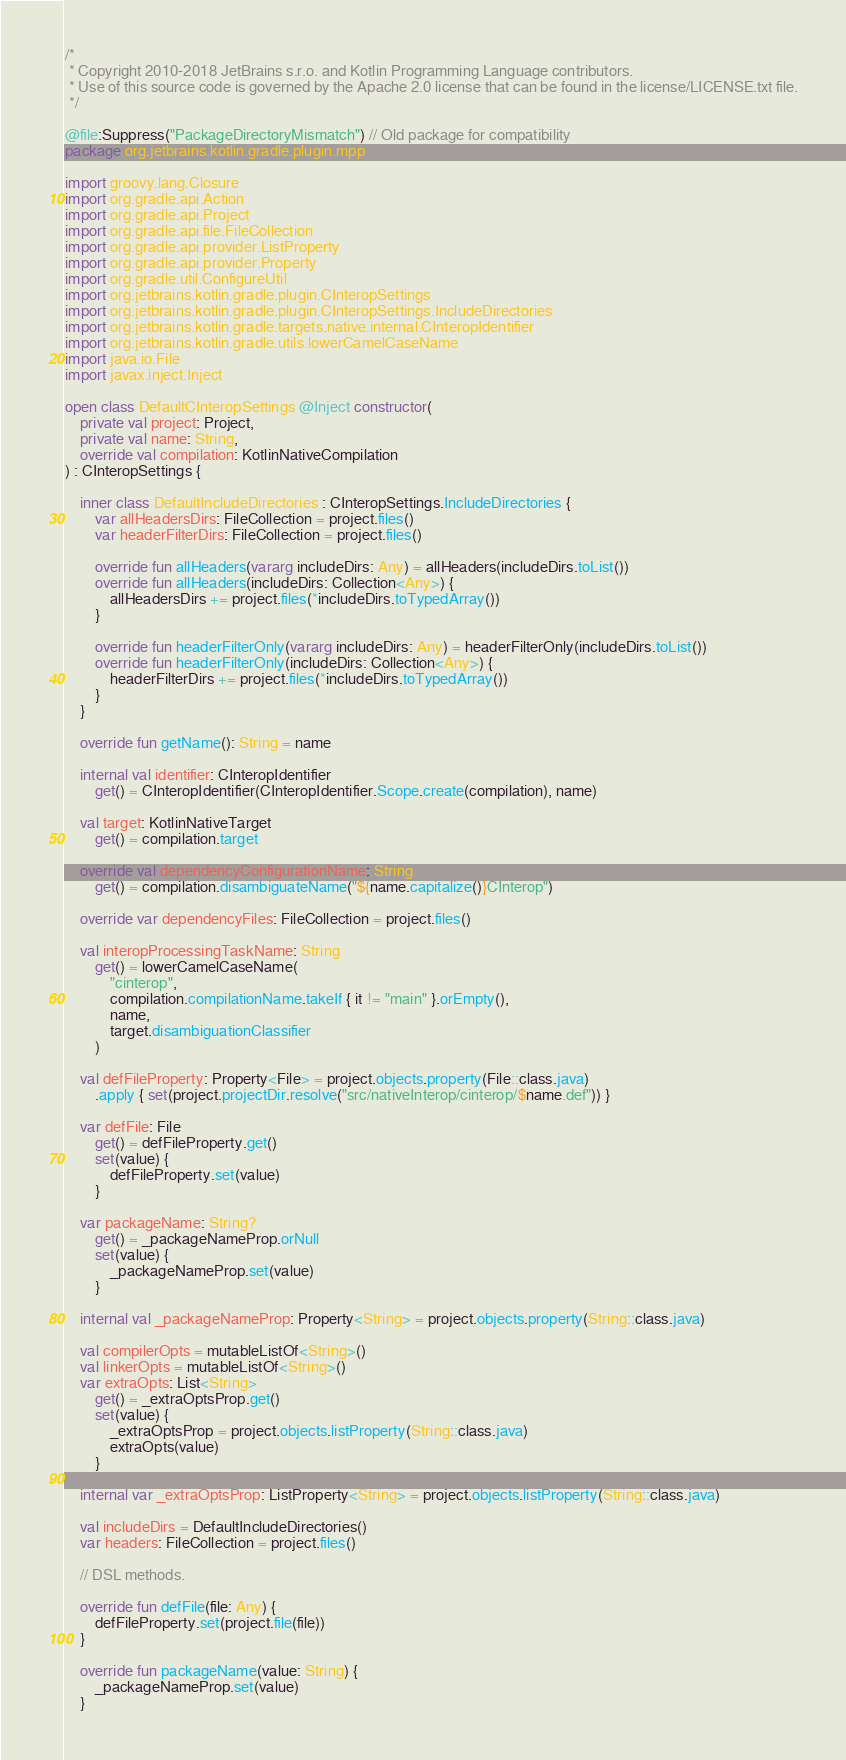<code> <loc_0><loc_0><loc_500><loc_500><_Kotlin_>/*
 * Copyright 2010-2018 JetBrains s.r.o. and Kotlin Programming Language contributors.
 * Use of this source code is governed by the Apache 2.0 license that can be found in the license/LICENSE.txt file.
 */

@file:Suppress("PackageDirectoryMismatch") // Old package for compatibility
package org.jetbrains.kotlin.gradle.plugin.mpp

import groovy.lang.Closure
import org.gradle.api.Action
import org.gradle.api.Project
import org.gradle.api.file.FileCollection
import org.gradle.api.provider.ListProperty
import org.gradle.api.provider.Property
import org.gradle.util.ConfigureUtil
import org.jetbrains.kotlin.gradle.plugin.CInteropSettings
import org.jetbrains.kotlin.gradle.plugin.CInteropSettings.IncludeDirectories
import org.jetbrains.kotlin.gradle.targets.native.internal.CInteropIdentifier
import org.jetbrains.kotlin.gradle.utils.lowerCamelCaseName
import java.io.File
import javax.inject.Inject

open class DefaultCInteropSettings @Inject constructor(
    private val project: Project,
    private val name: String,
    override val compilation: KotlinNativeCompilation
) : CInteropSettings {

    inner class DefaultIncludeDirectories : CInteropSettings.IncludeDirectories {
        var allHeadersDirs: FileCollection = project.files()
        var headerFilterDirs: FileCollection = project.files()

        override fun allHeaders(vararg includeDirs: Any) = allHeaders(includeDirs.toList())
        override fun allHeaders(includeDirs: Collection<Any>) {
            allHeadersDirs += project.files(*includeDirs.toTypedArray())
        }

        override fun headerFilterOnly(vararg includeDirs: Any) = headerFilterOnly(includeDirs.toList())
        override fun headerFilterOnly(includeDirs: Collection<Any>) {
            headerFilterDirs += project.files(*includeDirs.toTypedArray())
        }
    }

    override fun getName(): String = name

    internal val identifier: CInteropIdentifier
        get() = CInteropIdentifier(CInteropIdentifier.Scope.create(compilation), name)

    val target: KotlinNativeTarget
        get() = compilation.target

    override val dependencyConfigurationName: String
        get() = compilation.disambiguateName("${name.capitalize()}CInterop")

    override var dependencyFiles: FileCollection = project.files()

    val interopProcessingTaskName: String
        get() = lowerCamelCaseName(
            "cinterop",
            compilation.compilationName.takeIf { it != "main" }.orEmpty(),
            name,
            target.disambiguationClassifier
        )

    val defFileProperty: Property<File> = project.objects.property(File::class.java)
        .apply { set(project.projectDir.resolve("src/nativeInterop/cinterop/$name.def")) }

    var defFile: File
        get() = defFileProperty.get()
        set(value) {
            defFileProperty.set(value)
        }

    var packageName: String?
        get() = _packageNameProp.orNull
        set(value) {
            _packageNameProp.set(value)
        }

    internal val _packageNameProp: Property<String> = project.objects.property(String::class.java)

    val compilerOpts = mutableListOf<String>()
    val linkerOpts = mutableListOf<String>()
    var extraOpts: List<String>
        get() = _extraOptsProp.get()
        set(value) {
            _extraOptsProp = project.objects.listProperty(String::class.java)
            extraOpts(value)
        }

    internal var _extraOptsProp: ListProperty<String> = project.objects.listProperty(String::class.java)

    val includeDirs = DefaultIncludeDirectories()
    var headers: FileCollection = project.files()

    // DSL methods.

    override fun defFile(file: Any) {
        defFileProperty.set(project.file(file))
    }

    override fun packageName(value: String) {
        _packageNameProp.set(value)
    }
</code> 